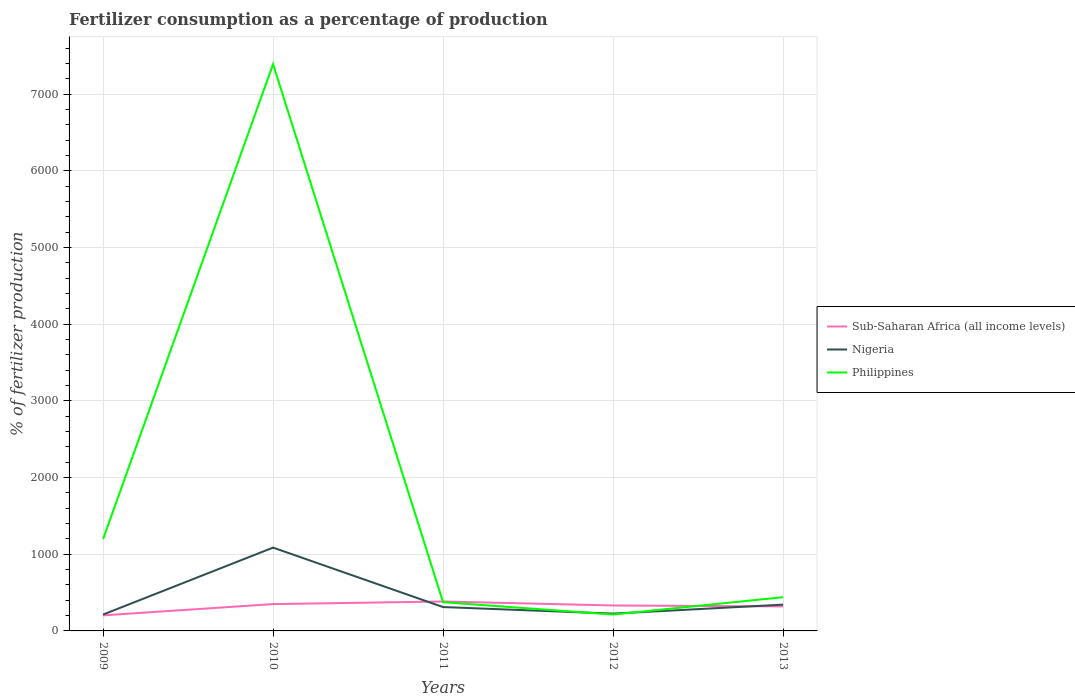How many different coloured lines are there?
Offer a terse response. 3. Does the line corresponding to Sub-Saharan Africa (all income levels) intersect with the line corresponding to Nigeria?
Provide a succinct answer. Yes. Is the number of lines equal to the number of legend labels?
Give a very brief answer. Yes. Across all years, what is the maximum percentage of fertilizers consumed in Philippines?
Your response must be concise. 213.56. In which year was the percentage of fertilizers consumed in Nigeria maximum?
Your response must be concise. 2009. What is the total percentage of fertilizers consumed in Sub-Saharan Africa (all income levels) in the graph?
Make the answer very short. -146.83. What is the difference between the highest and the second highest percentage of fertilizers consumed in Philippines?
Your response must be concise. 7177.62. Is the percentage of fertilizers consumed in Philippines strictly greater than the percentage of fertilizers consumed in Sub-Saharan Africa (all income levels) over the years?
Make the answer very short. No. How many years are there in the graph?
Offer a very short reply. 5. Are the values on the major ticks of Y-axis written in scientific E-notation?
Your answer should be compact. No. Does the graph contain grids?
Keep it short and to the point. Yes. Where does the legend appear in the graph?
Keep it short and to the point. Center right. What is the title of the graph?
Keep it short and to the point. Fertilizer consumption as a percentage of production. Does "Samoa" appear as one of the legend labels in the graph?
Offer a terse response. No. What is the label or title of the X-axis?
Offer a very short reply. Years. What is the label or title of the Y-axis?
Make the answer very short. % of fertilizer production. What is the % of fertilizer production of Sub-Saharan Africa (all income levels) in 2009?
Keep it short and to the point. 202.92. What is the % of fertilizer production of Nigeria in 2009?
Offer a terse response. 213.51. What is the % of fertilizer production in Philippines in 2009?
Make the answer very short. 1197.15. What is the % of fertilizer production of Sub-Saharan Africa (all income levels) in 2010?
Provide a short and direct response. 349.74. What is the % of fertilizer production in Nigeria in 2010?
Offer a very short reply. 1086.45. What is the % of fertilizer production in Philippines in 2010?
Make the answer very short. 7391.18. What is the % of fertilizer production in Sub-Saharan Africa (all income levels) in 2011?
Offer a terse response. 383.69. What is the % of fertilizer production of Nigeria in 2011?
Provide a succinct answer. 311.23. What is the % of fertilizer production in Philippines in 2011?
Give a very brief answer. 374.92. What is the % of fertilizer production of Sub-Saharan Africa (all income levels) in 2012?
Provide a succinct answer. 331.93. What is the % of fertilizer production of Nigeria in 2012?
Offer a terse response. 225.69. What is the % of fertilizer production of Philippines in 2012?
Offer a very short reply. 213.56. What is the % of fertilizer production in Sub-Saharan Africa (all income levels) in 2013?
Provide a succinct answer. 319.5. What is the % of fertilizer production of Nigeria in 2013?
Provide a short and direct response. 342.63. What is the % of fertilizer production of Philippines in 2013?
Your answer should be compact. 440.02. Across all years, what is the maximum % of fertilizer production of Sub-Saharan Africa (all income levels)?
Your answer should be compact. 383.69. Across all years, what is the maximum % of fertilizer production in Nigeria?
Offer a very short reply. 1086.45. Across all years, what is the maximum % of fertilizer production in Philippines?
Give a very brief answer. 7391.18. Across all years, what is the minimum % of fertilizer production in Sub-Saharan Africa (all income levels)?
Your answer should be compact. 202.92. Across all years, what is the minimum % of fertilizer production of Nigeria?
Provide a short and direct response. 213.51. Across all years, what is the minimum % of fertilizer production in Philippines?
Provide a short and direct response. 213.56. What is the total % of fertilizer production in Sub-Saharan Africa (all income levels) in the graph?
Give a very brief answer. 1587.78. What is the total % of fertilizer production of Nigeria in the graph?
Ensure brevity in your answer.  2179.51. What is the total % of fertilizer production in Philippines in the graph?
Provide a succinct answer. 9616.82. What is the difference between the % of fertilizer production in Sub-Saharan Africa (all income levels) in 2009 and that in 2010?
Provide a short and direct response. -146.83. What is the difference between the % of fertilizer production of Nigeria in 2009 and that in 2010?
Provide a short and direct response. -872.94. What is the difference between the % of fertilizer production of Philippines in 2009 and that in 2010?
Make the answer very short. -6194.03. What is the difference between the % of fertilizer production in Sub-Saharan Africa (all income levels) in 2009 and that in 2011?
Offer a terse response. -180.77. What is the difference between the % of fertilizer production in Nigeria in 2009 and that in 2011?
Keep it short and to the point. -97.72. What is the difference between the % of fertilizer production in Philippines in 2009 and that in 2011?
Your response must be concise. 822.23. What is the difference between the % of fertilizer production in Sub-Saharan Africa (all income levels) in 2009 and that in 2012?
Your answer should be compact. -129.01. What is the difference between the % of fertilizer production of Nigeria in 2009 and that in 2012?
Give a very brief answer. -12.18. What is the difference between the % of fertilizer production in Philippines in 2009 and that in 2012?
Provide a succinct answer. 983.59. What is the difference between the % of fertilizer production in Sub-Saharan Africa (all income levels) in 2009 and that in 2013?
Make the answer very short. -116.58. What is the difference between the % of fertilizer production of Nigeria in 2009 and that in 2013?
Your response must be concise. -129.13. What is the difference between the % of fertilizer production in Philippines in 2009 and that in 2013?
Make the answer very short. 757.13. What is the difference between the % of fertilizer production in Sub-Saharan Africa (all income levels) in 2010 and that in 2011?
Provide a short and direct response. -33.95. What is the difference between the % of fertilizer production of Nigeria in 2010 and that in 2011?
Make the answer very short. 775.22. What is the difference between the % of fertilizer production of Philippines in 2010 and that in 2011?
Provide a succinct answer. 7016.26. What is the difference between the % of fertilizer production in Sub-Saharan Africa (all income levels) in 2010 and that in 2012?
Offer a terse response. 17.81. What is the difference between the % of fertilizer production in Nigeria in 2010 and that in 2012?
Your answer should be compact. 860.76. What is the difference between the % of fertilizer production in Philippines in 2010 and that in 2012?
Your answer should be compact. 7177.62. What is the difference between the % of fertilizer production of Sub-Saharan Africa (all income levels) in 2010 and that in 2013?
Your answer should be very brief. 30.24. What is the difference between the % of fertilizer production of Nigeria in 2010 and that in 2013?
Your answer should be compact. 743.82. What is the difference between the % of fertilizer production of Philippines in 2010 and that in 2013?
Provide a succinct answer. 6951.16. What is the difference between the % of fertilizer production of Sub-Saharan Africa (all income levels) in 2011 and that in 2012?
Your answer should be very brief. 51.76. What is the difference between the % of fertilizer production of Nigeria in 2011 and that in 2012?
Make the answer very short. 85.54. What is the difference between the % of fertilizer production of Philippines in 2011 and that in 2012?
Your response must be concise. 161.36. What is the difference between the % of fertilizer production in Sub-Saharan Africa (all income levels) in 2011 and that in 2013?
Your response must be concise. 64.19. What is the difference between the % of fertilizer production in Nigeria in 2011 and that in 2013?
Your answer should be very brief. -31.4. What is the difference between the % of fertilizer production in Philippines in 2011 and that in 2013?
Provide a short and direct response. -65.1. What is the difference between the % of fertilizer production of Sub-Saharan Africa (all income levels) in 2012 and that in 2013?
Provide a succinct answer. 12.43. What is the difference between the % of fertilizer production of Nigeria in 2012 and that in 2013?
Your response must be concise. -116.95. What is the difference between the % of fertilizer production of Philippines in 2012 and that in 2013?
Provide a short and direct response. -226.46. What is the difference between the % of fertilizer production of Sub-Saharan Africa (all income levels) in 2009 and the % of fertilizer production of Nigeria in 2010?
Offer a terse response. -883.53. What is the difference between the % of fertilizer production of Sub-Saharan Africa (all income levels) in 2009 and the % of fertilizer production of Philippines in 2010?
Your answer should be very brief. -7188.26. What is the difference between the % of fertilizer production of Nigeria in 2009 and the % of fertilizer production of Philippines in 2010?
Offer a terse response. -7177.67. What is the difference between the % of fertilizer production of Sub-Saharan Africa (all income levels) in 2009 and the % of fertilizer production of Nigeria in 2011?
Offer a terse response. -108.32. What is the difference between the % of fertilizer production of Sub-Saharan Africa (all income levels) in 2009 and the % of fertilizer production of Philippines in 2011?
Provide a short and direct response. -172. What is the difference between the % of fertilizer production of Nigeria in 2009 and the % of fertilizer production of Philippines in 2011?
Give a very brief answer. -161.41. What is the difference between the % of fertilizer production of Sub-Saharan Africa (all income levels) in 2009 and the % of fertilizer production of Nigeria in 2012?
Your response must be concise. -22.77. What is the difference between the % of fertilizer production of Sub-Saharan Africa (all income levels) in 2009 and the % of fertilizer production of Philippines in 2012?
Your answer should be very brief. -10.65. What is the difference between the % of fertilizer production of Nigeria in 2009 and the % of fertilizer production of Philippines in 2012?
Offer a terse response. -0.05. What is the difference between the % of fertilizer production of Sub-Saharan Africa (all income levels) in 2009 and the % of fertilizer production of Nigeria in 2013?
Offer a terse response. -139.72. What is the difference between the % of fertilizer production of Sub-Saharan Africa (all income levels) in 2009 and the % of fertilizer production of Philippines in 2013?
Your answer should be very brief. -237.1. What is the difference between the % of fertilizer production of Nigeria in 2009 and the % of fertilizer production of Philippines in 2013?
Offer a terse response. -226.51. What is the difference between the % of fertilizer production of Sub-Saharan Africa (all income levels) in 2010 and the % of fertilizer production of Nigeria in 2011?
Make the answer very short. 38.51. What is the difference between the % of fertilizer production of Sub-Saharan Africa (all income levels) in 2010 and the % of fertilizer production of Philippines in 2011?
Offer a very short reply. -25.17. What is the difference between the % of fertilizer production of Nigeria in 2010 and the % of fertilizer production of Philippines in 2011?
Provide a succinct answer. 711.53. What is the difference between the % of fertilizer production of Sub-Saharan Africa (all income levels) in 2010 and the % of fertilizer production of Nigeria in 2012?
Your answer should be very brief. 124.06. What is the difference between the % of fertilizer production in Sub-Saharan Africa (all income levels) in 2010 and the % of fertilizer production in Philippines in 2012?
Your response must be concise. 136.18. What is the difference between the % of fertilizer production in Nigeria in 2010 and the % of fertilizer production in Philippines in 2012?
Give a very brief answer. 872.89. What is the difference between the % of fertilizer production in Sub-Saharan Africa (all income levels) in 2010 and the % of fertilizer production in Nigeria in 2013?
Your answer should be very brief. 7.11. What is the difference between the % of fertilizer production of Sub-Saharan Africa (all income levels) in 2010 and the % of fertilizer production of Philippines in 2013?
Your response must be concise. -90.28. What is the difference between the % of fertilizer production of Nigeria in 2010 and the % of fertilizer production of Philippines in 2013?
Offer a very short reply. 646.43. What is the difference between the % of fertilizer production in Sub-Saharan Africa (all income levels) in 2011 and the % of fertilizer production in Nigeria in 2012?
Your answer should be very brief. 158. What is the difference between the % of fertilizer production of Sub-Saharan Africa (all income levels) in 2011 and the % of fertilizer production of Philippines in 2012?
Provide a short and direct response. 170.13. What is the difference between the % of fertilizer production in Nigeria in 2011 and the % of fertilizer production in Philippines in 2012?
Your answer should be compact. 97.67. What is the difference between the % of fertilizer production in Sub-Saharan Africa (all income levels) in 2011 and the % of fertilizer production in Nigeria in 2013?
Offer a very short reply. 41.06. What is the difference between the % of fertilizer production in Sub-Saharan Africa (all income levels) in 2011 and the % of fertilizer production in Philippines in 2013?
Your answer should be very brief. -56.33. What is the difference between the % of fertilizer production in Nigeria in 2011 and the % of fertilizer production in Philippines in 2013?
Provide a succinct answer. -128.79. What is the difference between the % of fertilizer production of Sub-Saharan Africa (all income levels) in 2012 and the % of fertilizer production of Nigeria in 2013?
Offer a terse response. -10.7. What is the difference between the % of fertilizer production in Sub-Saharan Africa (all income levels) in 2012 and the % of fertilizer production in Philippines in 2013?
Ensure brevity in your answer.  -108.09. What is the difference between the % of fertilizer production in Nigeria in 2012 and the % of fertilizer production in Philippines in 2013?
Provide a succinct answer. -214.33. What is the average % of fertilizer production of Sub-Saharan Africa (all income levels) per year?
Provide a succinct answer. 317.56. What is the average % of fertilizer production in Nigeria per year?
Your response must be concise. 435.9. What is the average % of fertilizer production of Philippines per year?
Offer a very short reply. 1923.36. In the year 2009, what is the difference between the % of fertilizer production in Sub-Saharan Africa (all income levels) and % of fertilizer production in Nigeria?
Ensure brevity in your answer.  -10.59. In the year 2009, what is the difference between the % of fertilizer production in Sub-Saharan Africa (all income levels) and % of fertilizer production in Philippines?
Your response must be concise. -994.23. In the year 2009, what is the difference between the % of fertilizer production in Nigeria and % of fertilizer production in Philippines?
Offer a terse response. -983.64. In the year 2010, what is the difference between the % of fertilizer production of Sub-Saharan Africa (all income levels) and % of fertilizer production of Nigeria?
Provide a short and direct response. -736.71. In the year 2010, what is the difference between the % of fertilizer production in Sub-Saharan Africa (all income levels) and % of fertilizer production in Philippines?
Offer a terse response. -7041.43. In the year 2010, what is the difference between the % of fertilizer production in Nigeria and % of fertilizer production in Philippines?
Your answer should be compact. -6304.73. In the year 2011, what is the difference between the % of fertilizer production in Sub-Saharan Africa (all income levels) and % of fertilizer production in Nigeria?
Your answer should be very brief. 72.46. In the year 2011, what is the difference between the % of fertilizer production in Sub-Saharan Africa (all income levels) and % of fertilizer production in Philippines?
Offer a terse response. 8.77. In the year 2011, what is the difference between the % of fertilizer production of Nigeria and % of fertilizer production of Philippines?
Your answer should be compact. -63.69. In the year 2012, what is the difference between the % of fertilizer production of Sub-Saharan Africa (all income levels) and % of fertilizer production of Nigeria?
Offer a terse response. 106.24. In the year 2012, what is the difference between the % of fertilizer production of Sub-Saharan Africa (all income levels) and % of fertilizer production of Philippines?
Give a very brief answer. 118.37. In the year 2012, what is the difference between the % of fertilizer production of Nigeria and % of fertilizer production of Philippines?
Offer a very short reply. 12.13. In the year 2013, what is the difference between the % of fertilizer production of Sub-Saharan Africa (all income levels) and % of fertilizer production of Nigeria?
Ensure brevity in your answer.  -23.13. In the year 2013, what is the difference between the % of fertilizer production in Sub-Saharan Africa (all income levels) and % of fertilizer production in Philippines?
Keep it short and to the point. -120.52. In the year 2013, what is the difference between the % of fertilizer production of Nigeria and % of fertilizer production of Philippines?
Offer a very short reply. -97.39. What is the ratio of the % of fertilizer production in Sub-Saharan Africa (all income levels) in 2009 to that in 2010?
Provide a succinct answer. 0.58. What is the ratio of the % of fertilizer production of Nigeria in 2009 to that in 2010?
Give a very brief answer. 0.2. What is the ratio of the % of fertilizer production in Philippines in 2009 to that in 2010?
Your answer should be compact. 0.16. What is the ratio of the % of fertilizer production of Sub-Saharan Africa (all income levels) in 2009 to that in 2011?
Your answer should be very brief. 0.53. What is the ratio of the % of fertilizer production in Nigeria in 2009 to that in 2011?
Offer a terse response. 0.69. What is the ratio of the % of fertilizer production of Philippines in 2009 to that in 2011?
Keep it short and to the point. 3.19. What is the ratio of the % of fertilizer production in Sub-Saharan Africa (all income levels) in 2009 to that in 2012?
Give a very brief answer. 0.61. What is the ratio of the % of fertilizer production of Nigeria in 2009 to that in 2012?
Keep it short and to the point. 0.95. What is the ratio of the % of fertilizer production in Philippines in 2009 to that in 2012?
Make the answer very short. 5.61. What is the ratio of the % of fertilizer production in Sub-Saharan Africa (all income levels) in 2009 to that in 2013?
Provide a succinct answer. 0.64. What is the ratio of the % of fertilizer production of Nigeria in 2009 to that in 2013?
Give a very brief answer. 0.62. What is the ratio of the % of fertilizer production of Philippines in 2009 to that in 2013?
Offer a very short reply. 2.72. What is the ratio of the % of fertilizer production of Sub-Saharan Africa (all income levels) in 2010 to that in 2011?
Give a very brief answer. 0.91. What is the ratio of the % of fertilizer production of Nigeria in 2010 to that in 2011?
Keep it short and to the point. 3.49. What is the ratio of the % of fertilizer production in Philippines in 2010 to that in 2011?
Make the answer very short. 19.71. What is the ratio of the % of fertilizer production of Sub-Saharan Africa (all income levels) in 2010 to that in 2012?
Offer a terse response. 1.05. What is the ratio of the % of fertilizer production of Nigeria in 2010 to that in 2012?
Offer a terse response. 4.81. What is the ratio of the % of fertilizer production in Philippines in 2010 to that in 2012?
Your answer should be compact. 34.61. What is the ratio of the % of fertilizer production of Sub-Saharan Africa (all income levels) in 2010 to that in 2013?
Make the answer very short. 1.09. What is the ratio of the % of fertilizer production in Nigeria in 2010 to that in 2013?
Your answer should be compact. 3.17. What is the ratio of the % of fertilizer production in Philippines in 2010 to that in 2013?
Your answer should be very brief. 16.8. What is the ratio of the % of fertilizer production of Sub-Saharan Africa (all income levels) in 2011 to that in 2012?
Offer a very short reply. 1.16. What is the ratio of the % of fertilizer production of Nigeria in 2011 to that in 2012?
Offer a very short reply. 1.38. What is the ratio of the % of fertilizer production of Philippines in 2011 to that in 2012?
Your answer should be compact. 1.76. What is the ratio of the % of fertilizer production in Sub-Saharan Africa (all income levels) in 2011 to that in 2013?
Provide a short and direct response. 1.2. What is the ratio of the % of fertilizer production in Nigeria in 2011 to that in 2013?
Keep it short and to the point. 0.91. What is the ratio of the % of fertilizer production in Philippines in 2011 to that in 2013?
Provide a succinct answer. 0.85. What is the ratio of the % of fertilizer production in Sub-Saharan Africa (all income levels) in 2012 to that in 2013?
Offer a very short reply. 1.04. What is the ratio of the % of fertilizer production of Nigeria in 2012 to that in 2013?
Your answer should be very brief. 0.66. What is the ratio of the % of fertilizer production of Philippines in 2012 to that in 2013?
Your response must be concise. 0.49. What is the difference between the highest and the second highest % of fertilizer production in Sub-Saharan Africa (all income levels)?
Make the answer very short. 33.95. What is the difference between the highest and the second highest % of fertilizer production of Nigeria?
Offer a terse response. 743.82. What is the difference between the highest and the second highest % of fertilizer production of Philippines?
Provide a short and direct response. 6194.03. What is the difference between the highest and the lowest % of fertilizer production in Sub-Saharan Africa (all income levels)?
Provide a succinct answer. 180.77. What is the difference between the highest and the lowest % of fertilizer production of Nigeria?
Ensure brevity in your answer.  872.94. What is the difference between the highest and the lowest % of fertilizer production in Philippines?
Offer a terse response. 7177.62. 